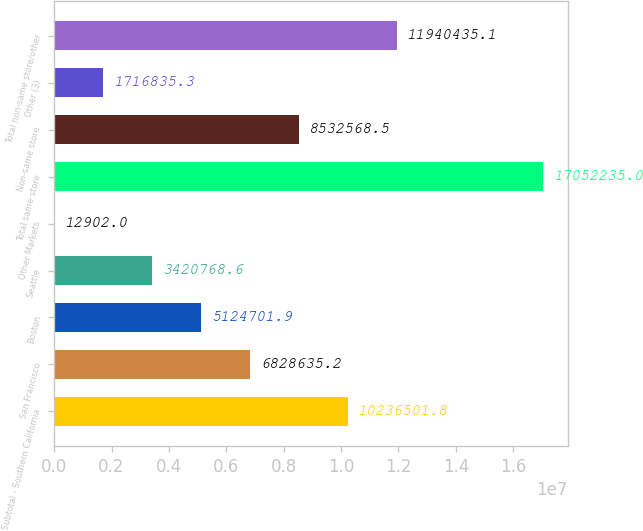<chart> <loc_0><loc_0><loc_500><loc_500><bar_chart><fcel>Subtotal - Southern California<fcel>San Francisco<fcel>Boston<fcel>Seattle<fcel>Other Markets<fcel>Total same store<fcel>Non-same store<fcel>Other (3)<fcel>Total non-same store/other<nl><fcel>1.02365e+07<fcel>6.82864e+06<fcel>5.1247e+06<fcel>3.42077e+06<fcel>12902<fcel>1.70522e+07<fcel>8.53257e+06<fcel>1.71684e+06<fcel>1.19404e+07<nl></chart> 